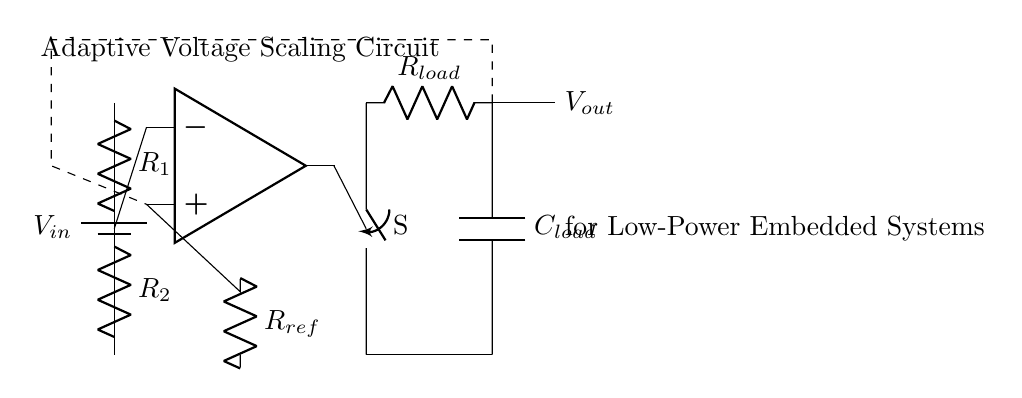What is the input voltage labeled as in the circuit? The input voltage is labeled as V sub in and is represented by a battery symbol at the top left of the circuit diagram.
Answer: V in What components are used in the voltage divider? The voltage divider consists of two resistors labeled as R sub 1 and R sub 2, which are connected in series between the input and ground.
Answer: R1 and R2 What type of component is the op-amp in the circuit? The component is indicated as an operational amplifier, which is typically used for comparing voltages in various applications.
Answer: Operational amplifier What function does the voltage-controlled switch serve in this circuit? The voltage-controlled switch allows or interrupts the flow of current based on the output from the op-amp, thereby controlling the connection to the load.
Answer: Control load connection How is the feedback incorporated in the circuit? The feedback is shown with a dashed line connecting the output to the non-inverting input of the op-amp, indicating that the output voltage influences the op-amp's input.
Answer: Through dashed line feedback What is the purpose of the capacitor labeled as C_load? The capacitor serves to smooth out the fluctuations in voltage across the load, helping to provide a stable output voltage under varying load conditions.
Answer: Smoothing voltage fluctuations 